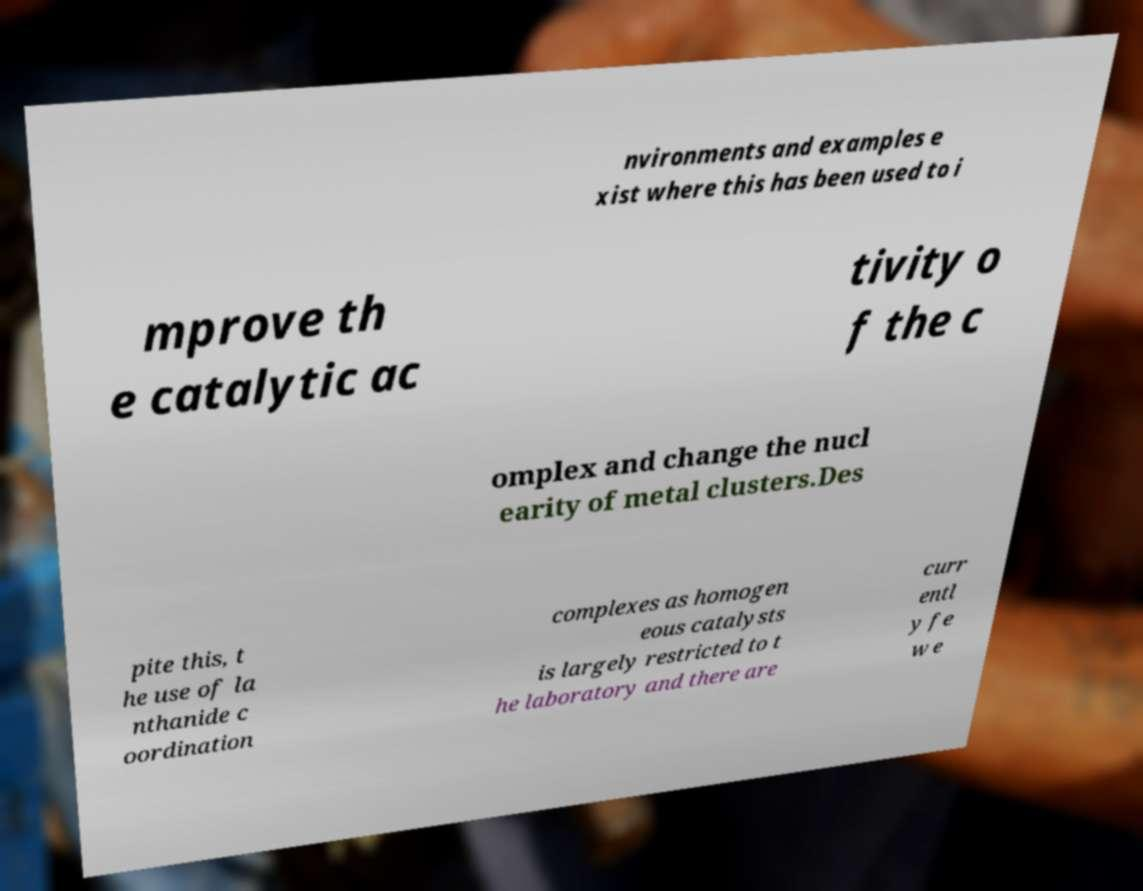What messages or text are displayed in this image? I need them in a readable, typed format. nvironments and examples e xist where this has been used to i mprove th e catalytic ac tivity o f the c omplex and change the nucl earity of metal clusters.Des pite this, t he use of la nthanide c oordination complexes as homogen eous catalysts is largely restricted to t he laboratory and there are curr entl y fe w e 